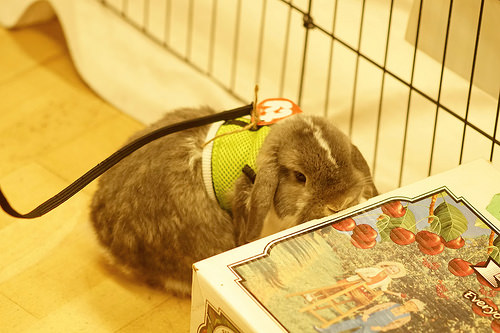<image>
Is there a harness on the rabbit? Yes. Looking at the image, I can see the harness is positioned on top of the rabbit, with the rabbit providing support. 